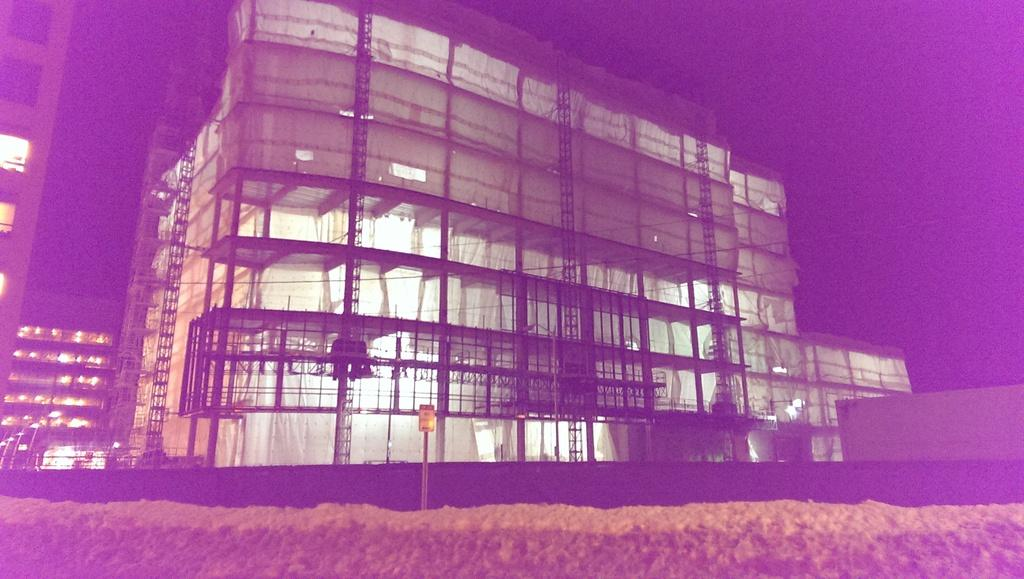What is the main subject in the middle of the image? There is a signal in the middle of the image. What can be seen near the signal? There is a building near the signal. What is visible in the background of the image? The background of the image is the sky. What type of paint is being used to cover the coal in the image? There is no coal or paint present in the image. 